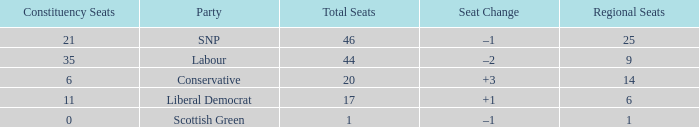How many regional seats were there with the SNP party and where the number of total seats was bigger than 46? 0.0. 